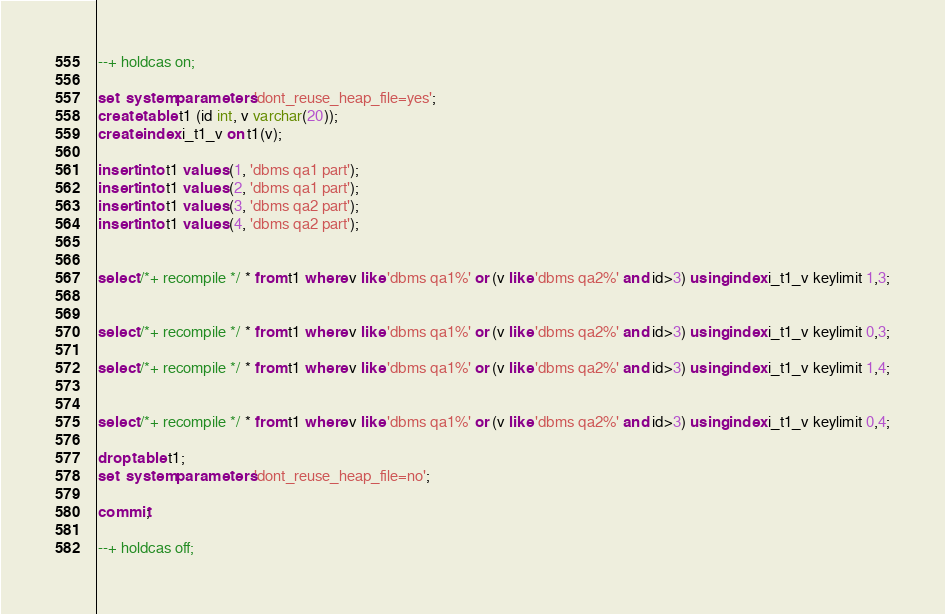Convert code to text. <code><loc_0><loc_0><loc_500><loc_500><_SQL_>--+ holdcas on;

set  system parameters 'dont_reuse_heap_file=yes';
create table t1 (id int, v varchar(20));
create index i_t1_v on t1(v);

insert into t1 values (1, 'dbms qa1 part');
insert into t1 values (2, 'dbms qa1 part');
insert into t1 values (3, 'dbms qa2 part');
insert into t1 values (4, 'dbms qa2 part');


select /*+ recompile */ * from t1 where v like 'dbms qa1%' or (v like 'dbms qa2%' and id>3) using index i_t1_v keylimit 1,3;


select /*+ recompile */ * from t1 where v like 'dbms qa1%' or (v like 'dbms qa2%' and id>3) using index i_t1_v keylimit 0,3;

select /*+ recompile */ * from t1 where v like 'dbms qa1%' or (v like 'dbms qa2%' and id>3) using index i_t1_v keylimit 1,4;


select /*+ recompile */ * from t1 where v like 'dbms qa1%' or (v like 'dbms qa2%' and id>3) using index i_t1_v keylimit 0,4;

drop table t1;
set  system parameters 'dont_reuse_heap_file=no';

commit;

--+ holdcas off;

</code> 